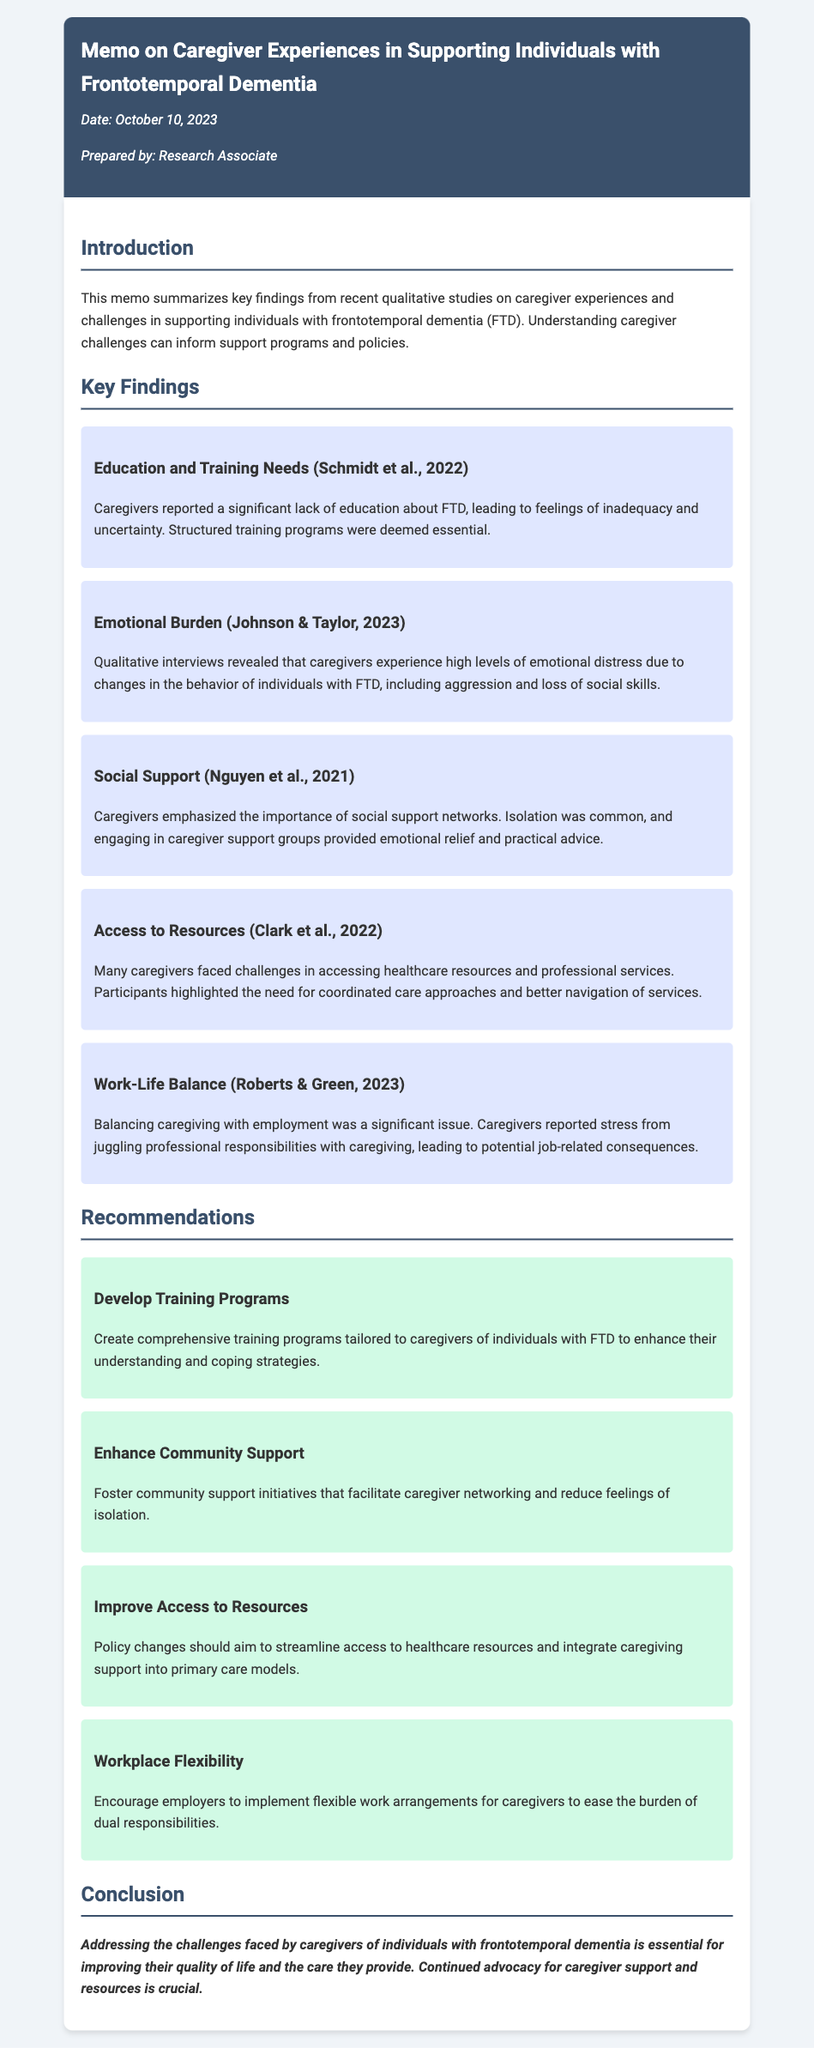What is the date of the memo? The date of the memo is mentioned at the top under the memo header.
Answer: October 10, 2023 Who prepared the memo? The name of the individual who prepared the memo is indicated below the date.
Answer: Research Associate What is one key finding related to caregiver education? The memo lists key findings, one of which discusses education and training needs.
Answer: Lack of education about FTD What emotional issue do caregivers face according to Johnson & Taylor, 2023? This issue is depicted under the emotional burden section of the key findings.
Answer: Emotional distress Which support system is emphasized in Nguyen et al., 2021's finding? The importance of this system is highlighted in the social support section of the document.
Answer: Social support networks How many recommendations are provided in the memo? The recommendations section lists several initiatives to support caregivers.
Answer: Four What is one recommendation for workplace policies? This recommendation is specified in the section dedicated to recommendations.
Answer: Flexible work arrangements Which study year is associated with the key finding on access to resources? The citation in the key finding on access to resources indicates the year of the study.
Answer: 2022 What is the conclusion stated in the memo? The conclusion section summarizes the overall takeaway from the memo.
Answer: Addressing the challenges faced by caregivers of individuals with frontotemporal dementia is essential 